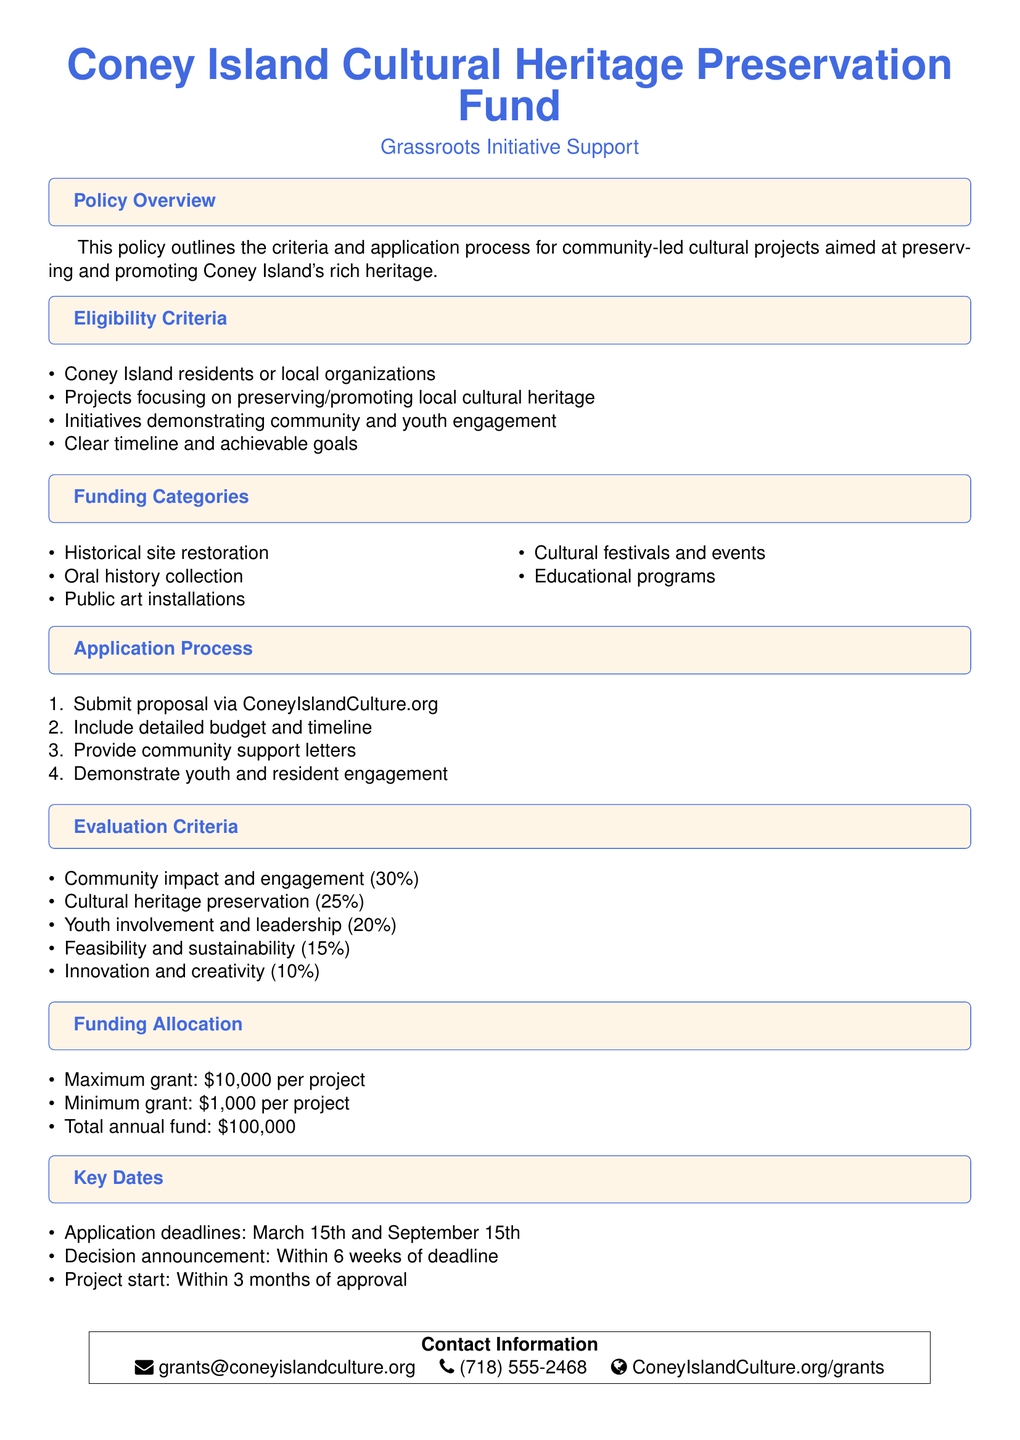What is the maximum grant amount for a project? The maximum grant is specified in the funding allocation section of the document, which states the maximum grant amount is $10,000.
Answer: $10,000 Who is eligible to apply for funding? Eligibility criteria specify that Coney Island residents or local organizations can apply for funding.
Answer: Coney Island residents or local organizations What percentage of the evaluation criteria is based on community impact and engagement? The evaluation criteria section delineates the percentages for different factors, with community impact and engagement making up 30 percent.
Answer: 30 percent When are the application deadlines? The key dates section highlights that the application deadlines are March 15th and September 15th.
Answer: March 15th and September 15th What is the minimum grant amount for a project? According to the funding allocation, the minimum grant amount is mentioned explicitly.
Answer: $1,000 How many weeks after the deadline will decisions be announced? The document specifies that decision announcements will be made within 6 weeks of the application deadline.
Answer: 6 weeks What is one of the funding categories listed? The funding categories section lists several project types, one of which can be found in this list.
Answer: Public art installations What is the total annual fund available? The funding allocation section indicates the total annual fund available for projects.
Answer: $100,000 What must be included in the proposal submission? The application process outlines that a detailed budget and timeline must be included in the proposal submission.
Answer: Detailed budget and timeline 